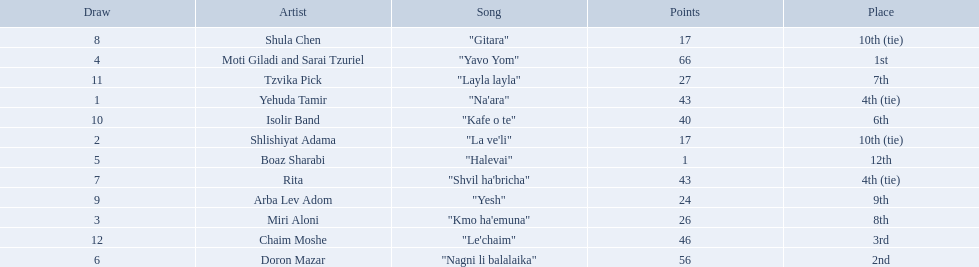What are the points in the competition? 43, 17, 26, 66, 1, 56, 43, 17, 24, 40, 27, 46. What is the lowest points? 1. What artist received these points? Boaz Sharabi. 